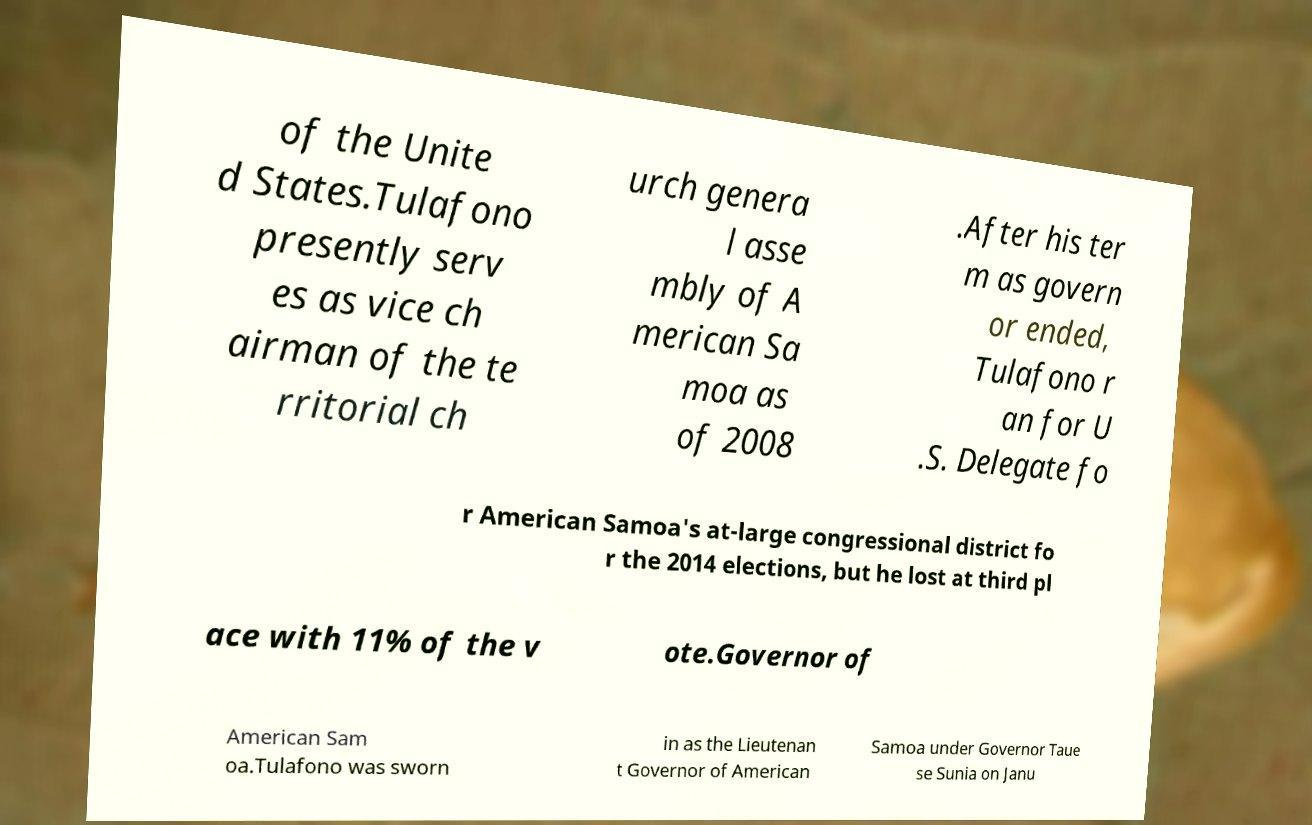Could you extract and type out the text from this image? of the Unite d States.Tulafono presently serv es as vice ch airman of the te rritorial ch urch genera l asse mbly of A merican Sa moa as of 2008 .After his ter m as govern or ended, Tulafono r an for U .S. Delegate fo r American Samoa's at-large congressional district fo r the 2014 elections, but he lost at third pl ace with 11% of the v ote.Governor of American Sam oa.Tulafono was sworn in as the Lieutenan t Governor of American Samoa under Governor Taue se Sunia on Janu 